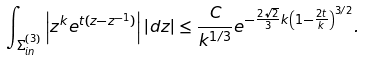<formula> <loc_0><loc_0><loc_500><loc_500>\int _ { \Sigma ^ { ( 3 ) } _ { i n } } \left | z ^ { k } e ^ { t ( z - z ^ { - 1 } ) } \right | | d z | \leq \frac { C } { k ^ { 1 / 3 } } e ^ { - \frac { 2 \sqrt { 2 } } { 3 } k \left ( 1 - \frac { 2 t } { k } \right ) ^ { 3 / 2 } } .</formula> 